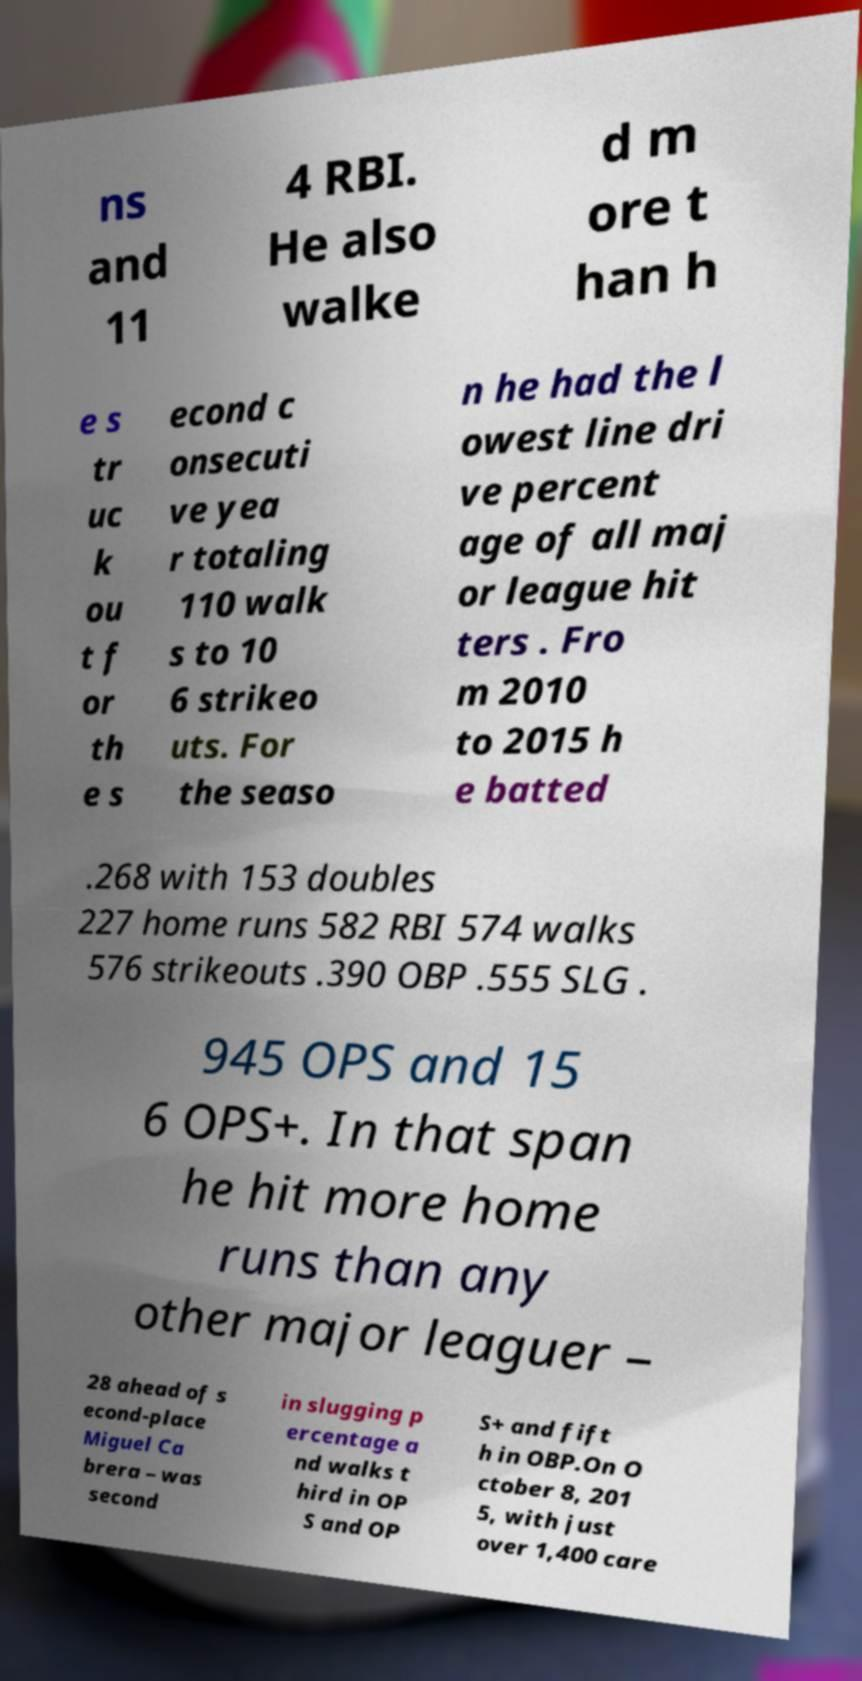There's text embedded in this image that I need extracted. Can you transcribe it verbatim? ns and 11 4 RBI. He also walke d m ore t han h e s tr uc k ou t f or th e s econd c onsecuti ve yea r totaling 110 walk s to 10 6 strikeo uts. For the seaso n he had the l owest line dri ve percent age of all maj or league hit ters . Fro m 2010 to 2015 h e batted .268 with 153 doubles 227 home runs 582 RBI 574 walks 576 strikeouts .390 OBP .555 SLG . 945 OPS and 15 6 OPS+. In that span he hit more home runs than any other major leaguer – 28 ahead of s econd-place Miguel Ca brera – was second in slugging p ercentage a nd walks t hird in OP S and OP S+ and fift h in OBP.On O ctober 8, 201 5, with just over 1,400 care 